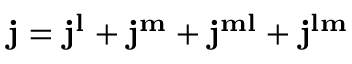Convert formula to latex. <formula><loc_0><loc_0><loc_500><loc_500>j = j ^ { l } + j ^ { m } + j ^ { m l } + j ^ { l m }</formula> 